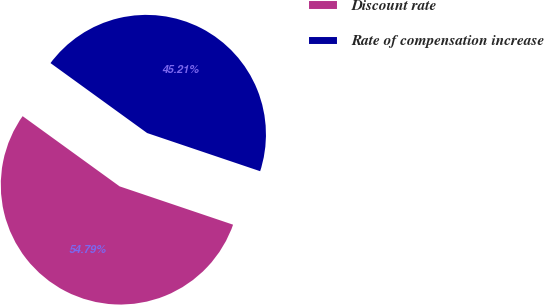Convert chart. <chart><loc_0><loc_0><loc_500><loc_500><pie_chart><fcel>Discount rate<fcel>Rate of compensation increase<nl><fcel>54.79%<fcel>45.21%<nl></chart> 